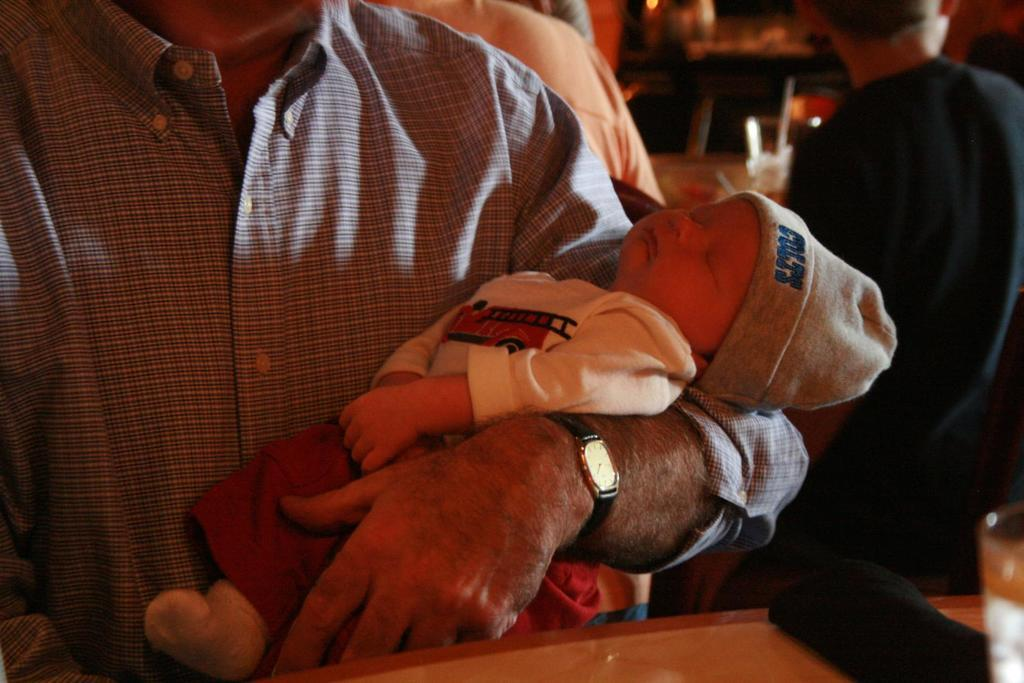<image>
Relay a brief, clear account of the picture shown. A baby that is held in a man's arms is wearing a Colt's beanie 